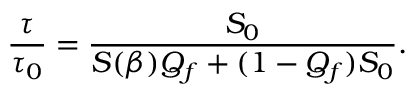Convert formula to latex. <formula><loc_0><loc_0><loc_500><loc_500>\frac { \tau } { \tau _ { 0 } } = \frac { S _ { 0 } } { S ( \beta ) Q _ { f } + ( 1 - Q _ { f } ) S _ { 0 } } .</formula> 